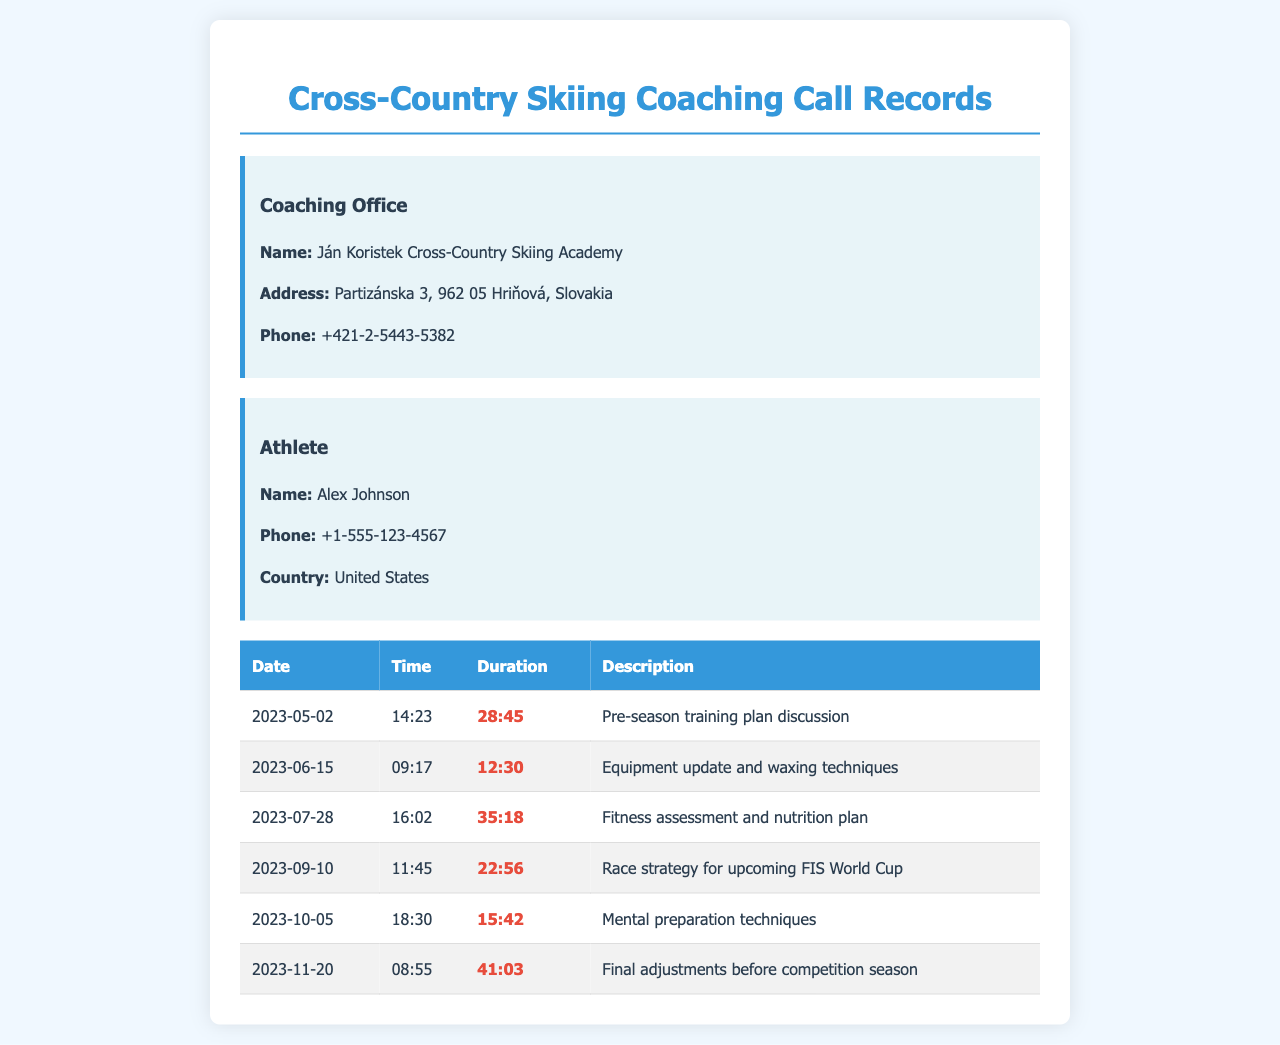what is the name of the coaching office? The document provides the name of the coaching office, which is listed at the beginning.
Answer: Ján Koristek Cross-Country Skiing Academy how many calls were made to Ján Koristek's office? By counting the rows in the call records table, we can find the total number of calls made.
Answer: 6 what was the duration of the call on June 15, 2023? The duration of the specific call on this date is stated directly in the call records.
Answer: 12:30 which call had the longest duration? Analyzing the duration of each call, we can identify the one with the maximum length.
Answer: 41:03 on what date was the call about race strategy made? The specific date concerning the race strategy discussion is indicated in the records.
Answer: 2023-09-10 how many calls were related to training or preparation? By reviewing the descriptions in the call records, we can determine how many calls pertained to training.
Answer: 4 